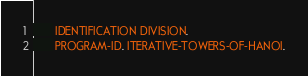Convert code to text. <code><loc_0><loc_0><loc_500><loc_500><_COBOL_>       IDENTIFICATION DIVISION.
       PROGRAM-ID. ITERATIVE-TOWERS-OF-HANOI.</code> 